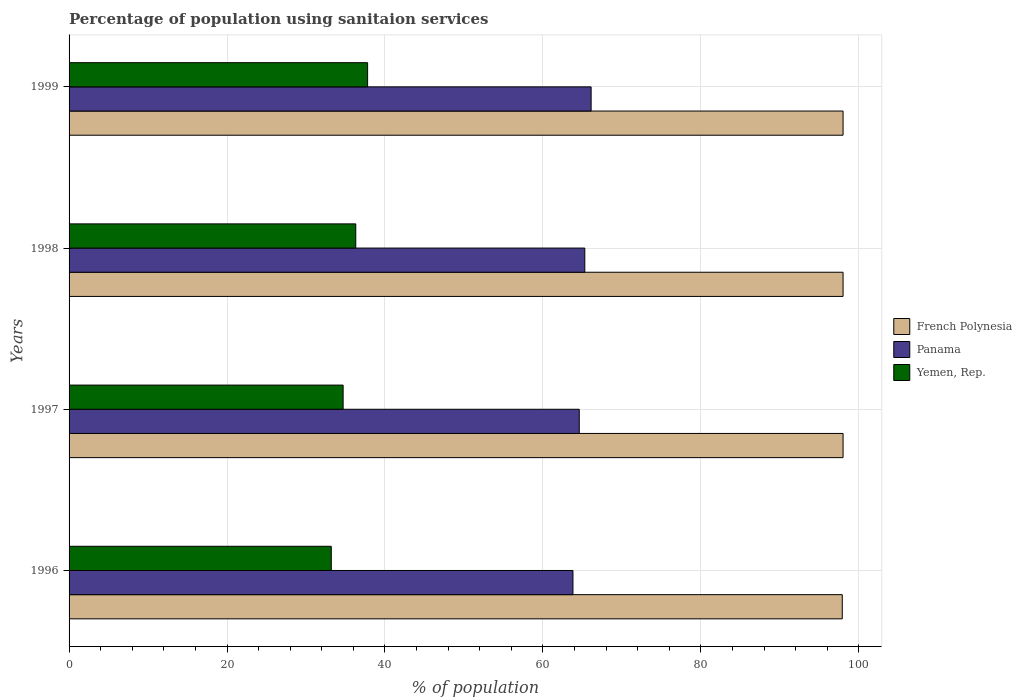Are the number of bars on each tick of the Y-axis equal?
Offer a terse response. Yes. How many bars are there on the 3rd tick from the bottom?
Offer a very short reply. 3. What is the label of the 3rd group of bars from the top?
Your response must be concise. 1997. In how many cases, is the number of bars for a given year not equal to the number of legend labels?
Keep it short and to the point. 0. What is the percentage of population using sanitaion services in Yemen, Rep. in 1998?
Ensure brevity in your answer.  36.3. Across all years, what is the maximum percentage of population using sanitaion services in French Polynesia?
Give a very brief answer. 98. Across all years, what is the minimum percentage of population using sanitaion services in French Polynesia?
Your answer should be compact. 97.9. In which year was the percentage of population using sanitaion services in French Polynesia minimum?
Your answer should be compact. 1996. What is the total percentage of population using sanitaion services in French Polynesia in the graph?
Make the answer very short. 391.9. What is the difference between the percentage of population using sanitaion services in French Polynesia in 1996 and that in 1997?
Your answer should be compact. -0.1. What is the difference between the percentage of population using sanitaion services in Panama in 1998 and the percentage of population using sanitaion services in French Polynesia in 1997?
Keep it short and to the point. -32.7. What is the average percentage of population using sanitaion services in French Polynesia per year?
Offer a very short reply. 97.97. In the year 1997, what is the difference between the percentage of population using sanitaion services in Panama and percentage of population using sanitaion services in French Polynesia?
Your answer should be very brief. -33.4. What is the ratio of the percentage of population using sanitaion services in Panama in 1998 to that in 1999?
Ensure brevity in your answer.  0.99. Is the percentage of population using sanitaion services in French Polynesia in 1998 less than that in 1999?
Your answer should be compact. No. Is the difference between the percentage of population using sanitaion services in Panama in 1996 and 1998 greater than the difference between the percentage of population using sanitaion services in French Polynesia in 1996 and 1998?
Offer a very short reply. No. What is the difference between the highest and the second highest percentage of population using sanitaion services in Yemen, Rep.?
Make the answer very short. 1.5. What is the difference between the highest and the lowest percentage of population using sanitaion services in Yemen, Rep.?
Your answer should be very brief. 4.6. Is the sum of the percentage of population using sanitaion services in Yemen, Rep. in 1998 and 1999 greater than the maximum percentage of population using sanitaion services in French Polynesia across all years?
Your answer should be very brief. No. What does the 3rd bar from the top in 1999 represents?
Your answer should be compact. French Polynesia. What does the 2nd bar from the bottom in 1996 represents?
Provide a succinct answer. Panama. How many bars are there?
Offer a very short reply. 12. How many years are there in the graph?
Ensure brevity in your answer.  4. What is the difference between two consecutive major ticks on the X-axis?
Your answer should be very brief. 20. Are the values on the major ticks of X-axis written in scientific E-notation?
Offer a very short reply. No. Does the graph contain any zero values?
Your answer should be very brief. No. Where does the legend appear in the graph?
Ensure brevity in your answer.  Center right. What is the title of the graph?
Make the answer very short. Percentage of population using sanitaion services. Does "Israel" appear as one of the legend labels in the graph?
Keep it short and to the point. No. What is the label or title of the X-axis?
Your answer should be compact. % of population. What is the label or title of the Y-axis?
Your answer should be compact. Years. What is the % of population in French Polynesia in 1996?
Make the answer very short. 97.9. What is the % of population in Panama in 1996?
Provide a succinct answer. 63.8. What is the % of population of Yemen, Rep. in 1996?
Provide a short and direct response. 33.2. What is the % of population of Panama in 1997?
Offer a terse response. 64.6. What is the % of population of Yemen, Rep. in 1997?
Provide a succinct answer. 34.7. What is the % of population in Panama in 1998?
Your answer should be compact. 65.3. What is the % of population in Yemen, Rep. in 1998?
Make the answer very short. 36.3. What is the % of population of Panama in 1999?
Your response must be concise. 66.1. What is the % of population of Yemen, Rep. in 1999?
Give a very brief answer. 37.8. Across all years, what is the maximum % of population of Panama?
Your response must be concise. 66.1. Across all years, what is the maximum % of population of Yemen, Rep.?
Your answer should be very brief. 37.8. Across all years, what is the minimum % of population in French Polynesia?
Make the answer very short. 97.9. Across all years, what is the minimum % of population of Panama?
Ensure brevity in your answer.  63.8. Across all years, what is the minimum % of population of Yemen, Rep.?
Your response must be concise. 33.2. What is the total % of population of French Polynesia in the graph?
Offer a very short reply. 391.9. What is the total % of population in Panama in the graph?
Your answer should be very brief. 259.8. What is the total % of population in Yemen, Rep. in the graph?
Your answer should be compact. 142. What is the difference between the % of population in French Polynesia in 1996 and that in 1997?
Make the answer very short. -0.1. What is the difference between the % of population of Panama in 1996 and that in 1997?
Offer a very short reply. -0.8. What is the difference between the % of population in Yemen, Rep. in 1996 and that in 1999?
Give a very brief answer. -4.6. What is the difference between the % of population of French Polynesia in 1997 and that in 1998?
Give a very brief answer. 0. What is the difference between the % of population of Panama in 1997 and that in 1998?
Make the answer very short. -0.7. What is the difference between the % of population of Yemen, Rep. in 1997 and that in 1998?
Your response must be concise. -1.6. What is the difference between the % of population in French Polynesia in 1997 and that in 1999?
Your answer should be very brief. 0. What is the difference between the % of population in Panama in 1998 and that in 1999?
Keep it short and to the point. -0.8. What is the difference between the % of population of Yemen, Rep. in 1998 and that in 1999?
Offer a very short reply. -1.5. What is the difference between the % of population of French Polynesia in 1996 and the % of population of Panama in 1997?
Offer a very short reply. 33.3. What is the difference between the % of population of French Polynesia in 1996 and the % of population of Yemen, Rep. in 1997?
Your answer should be compact. 63.2. What is the difference between the % of population in Panama in 1996 and the % of population in Yemen, Rep. in 1997?
Offer a very short reply. 29.1. What is the difference between the % of population of French Polynesia in 1996 and the % of population of Panama in 1998?
Keep it short and to the point. 32.6. What is the difference between the % of population of French Polynesia in 1996 and the % of population of Yemen, Rep. in 1998?
Your response must be concise. 61.6. What is the difference between the % of population in Panama in 1996 and the % of population in Yemen, Rep. in 1998?
Provide a short and direct response. 27.5. What is the difference between the % of population of French Polynesia in 1996 and the % of population of Panama in 1999?
Your response must be concise. 31.8. What is the difference between the % of population of French Polynesia in 1996 and the % of population of Yemen, Rep. in 1999?
Offer a very short reply. 60.1. What is the difference between the % of population in Panama in 1996 and the % of population in Yemen, Rep. in 1999?
Ensure brevity in your answer.  26. What is the difference between the % of population of French Polynesia in 1997 and the % of population of Panama in 1998?
Your answer should be compact. 32.7. What is the difference between the % of population in French Polynesia in 1997 and the % of population in Yemen, Rep. in 1998?
Offer a very short reply. 61.7. What is the difference between the % of population in Panama in 1997 and the % of population in Yemen, Rep. in 1998?
Make the answer very short. 28.3. What is the difference between the % of population of French Polynesia in 1997 and the % of population of Panama in 1999?
Provide a short and direct response. 31.9. What is the difference between the % of population in French Polynesia in 1997 and the % of population in Yemen, Rep. in 1999?
Make the answer very short. 60.2. What is the difference between the % of population in Panama in 1997 and the % of population in Yemen, Rep. in 1999?
Offer a very short reply. 26.8. What is the difference between the % of population in French Polynesia in 1998 and the % of population in Panama in 1999?
Your answer should be compact. 31.9. What is the difference between the % of population of French Polynesia in 1998 and the % of population of Yemen, Rep. in 1999?
Keep it short and to the point. 60.2. What is the difference between the % of population of Panama in 1998 and the % of population of Yemen, Rep. in 1999?
Give a very brief answer. 27.5. What is the average % of population of French Polynesia per year?
Make the answer very short. 97.97. What is the average % of population of Panama per year?
Your response must be concise. 64.95. What is the average % of population in Yemen, Rep. per year?
Give a very brief answer. 35.5. In the year 1996, what is the difference between the % of population in French Polynesia and % of population in Panama?
Offer a very short reply. 34.1. In the year 1996, what is the difference between the % of population of French Polynesia and % of population of Yemen, Rep.?
Your response must be concise. 64.7. In the year 1996, what is the difference between the % of population of Panama and % of population of Yemen, Rep.?
Your response must be concise. 30.6. In the year 1997, what is the difference between the % of population in French Polynesia and % of population in Panama?
Your answer should be very brief. 33.4. In the year 1997, what is the difference between the % of population in French Polynesia and % of population in Yemen, Rep.?
Make the answer very short. 63.3. In the year 1997, what is the difference between the % of population of Panama and % of population of Yemen, Rep.?
Offer a terse response. 29.9. In the year 1998, what is the difference between the % of population in French Polynesia and % of population in Panama?
Make the answer very short. 32.7. In the year 1998, what is the difference between the % of population in French Polynesia and % of population in Yemen, Rep.?
Offer a terse response. 61.7. In the year 1998, what is the difference between the % of population in Panama and % of population in Yemen, Rep.?
Your response must be concise. 29. In the year 1999, what is the difference between the % of population of French Polynesia and % of population of Panama?
Offer a terse response. 31.9. In the year 1999, what is the difference between the % of population in French Polynesia and % of population in Yemen, Rep.?
Your response must be concise. 60.2. In the year 1999, what is the difference between the % of population of Panama and % of population of Yemen, Rep.?
Make the answer very short. 28.3. What is the ratio of the % of population in French Polynesia in 1996 to that in 1997?
Keep it short and to the point. 1. What is the ratio of the % of population of Panama in 1996 to that in 1997?
Give a very brief answer. 0.99. What is the ratio of the % of population of Yemen, Rep. in 1996 to that in 1997?
Provide a succinct answer. 0.96. What is the ratio of the % of population in French Polynesia in 1996 to that in 1998?
Offer a terse response. 1. What is the ratio of the % of population of Yemen, Rep. in 1996 to that in 1998?
Give a very brief answer. 0.91. What is the ratio of the % of population in French Polynesia in 1996 to that in 1999?
Offer a very short reply. 1. What is the ratio of the % of population in Panama in 1996 to that in 1999?
Provide a short and direct response. 0.97. What is the ratio of the % of population of Yemen, Rep. in 1996 to that in 1999?
Offer a terse response. 0.88. What is the ratio of the % of population of French Polynesia in 1997 to that in 1998?
Your answer should be very brief. 1. What is the ratio of the % of population of Panama in 1997 to that in 1998?
Your answer should be compact. 0.99. What is the ratio of the % of population in Yemen, Rep. in 1997 to that in 1998?
Provide a short and direct response. 0.96. What is the ratio of the % of population in French Polynesia in 1997 to that in 1999?
Offer a terse response. 1. What is the ratio of the % of population in Panama in 1997 to that in 1999?
Your answer should be compact. 0.98. What is the ratio of the % of population of Yemen, Rep. in 1997 to that in 1999?
Provide a short and direct response. 0.92. What is the ratio of the % of population in Panama in 1998 to that in 1999?
Your answer should be very brief. 0.99. What is the ratio of the % of population in Yemen, Rep. in 1998 to that in 1999?
Offer a terse response. 0.96. What is the difference between the highest and the second highest % of population in French Polynesia?
Ensure brevity in your answer.  0. What is the difference between the highest and the second highest % of population of Panama?
Keep it short and to the point. 0.8. What is the difference between the highest and the lowest % of population of French Polynesia?
Your answer should be very brief. 0.1. What is the difference between the highest and the lowest % of population in Yemen, Rep.?
Your answer should be compact. 4.6. 